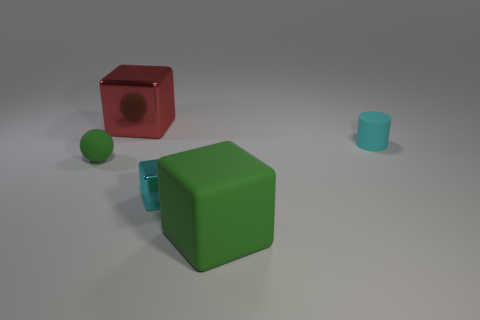Subtract all big red metal blocks. How many blocks are left? 2 Subtract all cyan blocks. How many blocks are left? 2 Subtract 1 cylinders. How many cylinders are left? 0 Add 3 rubber things. How many objects exist? 8 Subtract 0 purple cylinders. How many objects are left? 5 Subtract all cylinders. How many objects are left? 4 Subtract all cyan balls. Subtract all cyan cubes. How many balls are left? 1 Subtract all brown cylinders. How many cyan cubes are left? 1 Subtract all large brown matte cylinders. Subtract all green matte cubes. How many objects are left? 4 Add 5 large red metal blocks. How many large red metal blocks are left? 6 